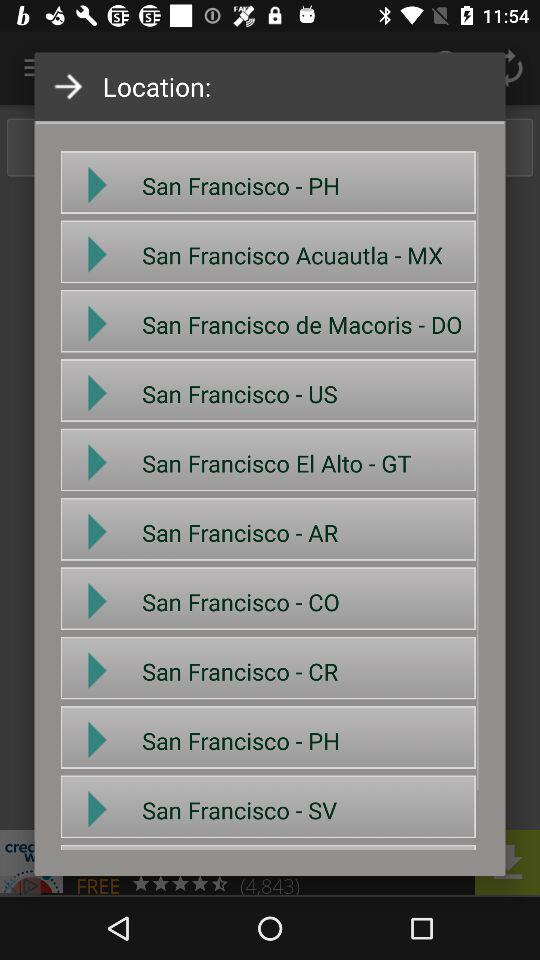How many San Francisco locations are there in total?
Answer the question using a single word or phrase. 10 